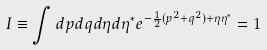<formula> <loc_0><loc_0><loc_500><loc_500>I \equiv \int d p d q d \eta d \eta ^ { * } e ^ { - \frac { 1 } { 2 } ( p ^ { 2 } + q ^ { 2 } ) + \eta \eta ^ { * } } = 1</formula> 